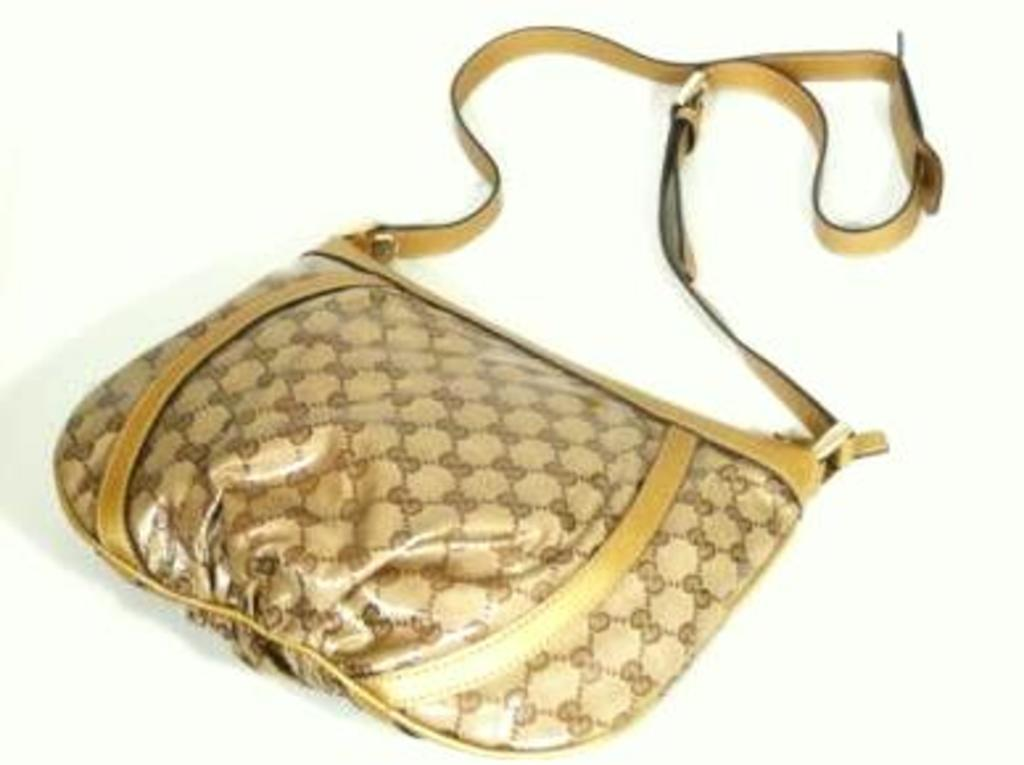What is the color and pattern of the bag in the image? The bag in the image is brown with yellow stripes. What is the color of the surface the bag is placed on? The bag is on a white surface. What type of veil can be seen covering the hill in the image? There is no veil or hill present in the image; it only features a brown bag with yellow stripes on a white surface. 